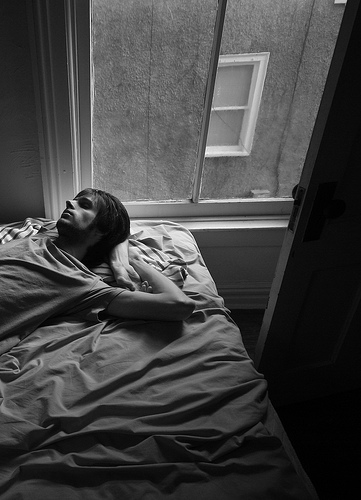Is the large window closed or open? The large window is open. 